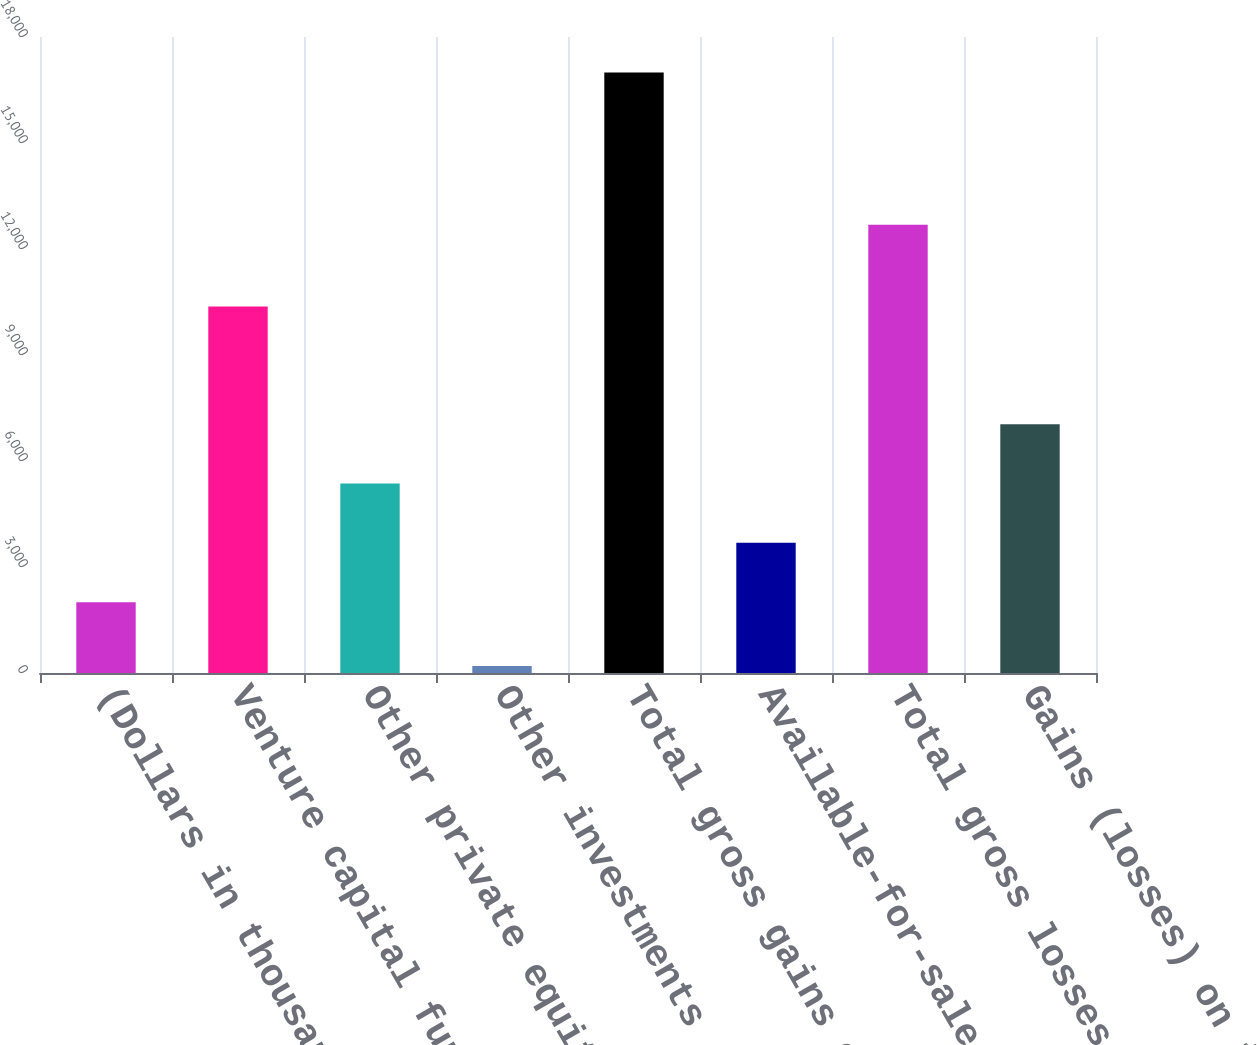Convert chart. <chart><loc_0><loc_0><loc_500><loc_500><bar_chart><fcel>(Dollars in thousands)<fcel>Venture capital fund<fcel>Other private equity<fcel>Other investments<fcel>Total gross gains on<fcel>Available-for-sale securities<fcel>Total gross losses on<fcel>Gains (losses) on investment<nl><fcel>2005<fcel>10375<fcel>5364<fcel>199<fcel>16994<fcel>3684.5<fcel>12687<fcel>7043.5<nl></chart> 